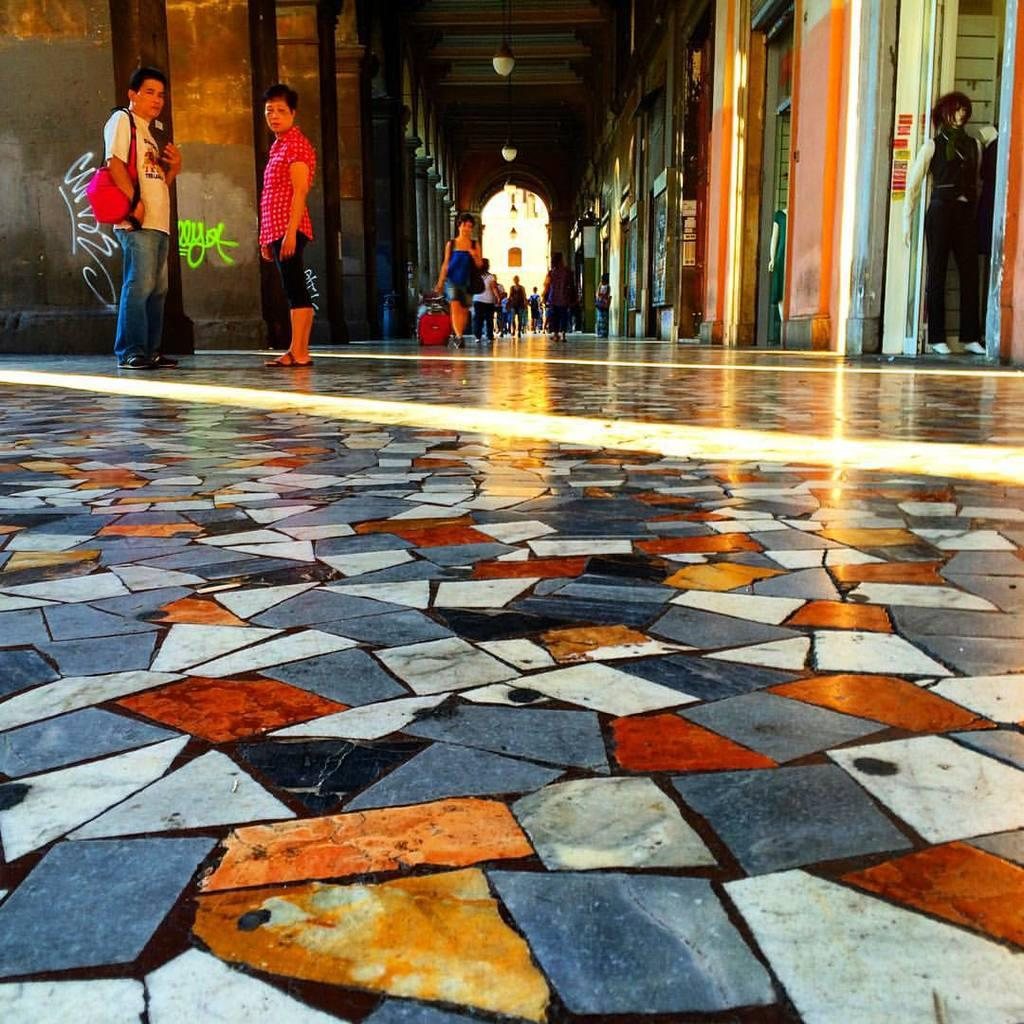What are the people in the image doing? The people in the image are walking in the corridor of the mall. What architectural features can be seen in the mall? There are pillars in the mall. What type of businesses are present in the mall? There are shops in the mall. What lighting source is visible in the image? There are lamps visible at the top of the image. What type of insurance policy is being discussed by the people walking in the mall? There is no indication in the image that the people walking in the mall are discussing any insurance policies. 